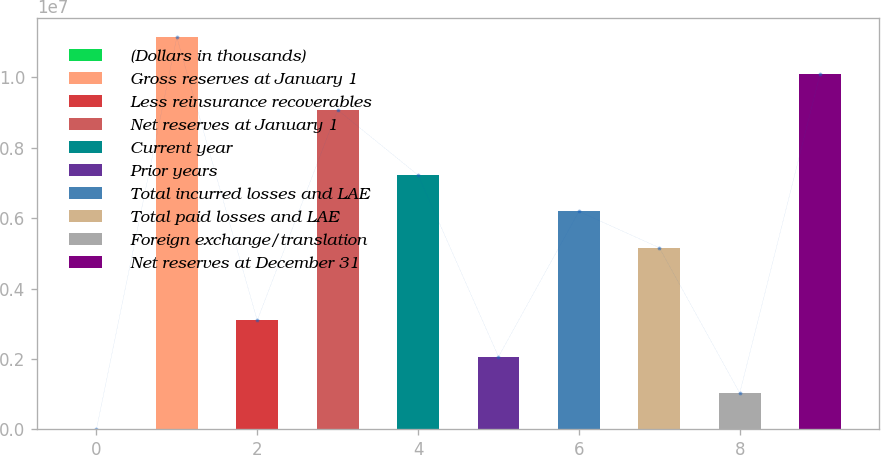Convert chart to OTSL. <chart><loc_0><loc_0><loc_500><loc_500><bar_chart><fcel>(Dollars in thousands)<fcel>Gross reserves at January 1<fcel>Less reinsurance recoverables<fcel>Net reserves at January 1<fcel>Current year<fcel>Prior years<fcel>Total incurred losses and LAE<fcel>Total paid losses and LAE<fcel>Foreign exchange/translation<fcel>Net reserves at December 31<nl><fcel>2016<fcel>1.11324e+07<fcel>3.09511e+06<fcel>9.0703e+06<fcel>7.21922e+06<fcel>2.06408e+06<fcel>6.18819e+06<fcel>5.15716e+06<fcel>1.03305e+06<fcel>1.01013e+07<nl></chart> 